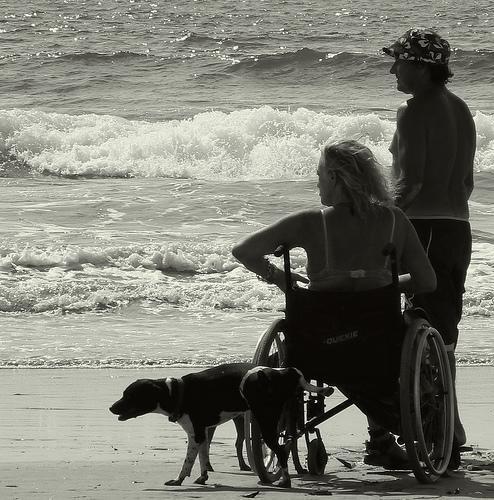How many dogs?
Give a very brief answer. 1. 